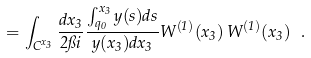Convert formula to latex. <formula><loc_0><loc_0><loc_500><loc_500>= \int _ { C ^ { x _ { 3 } } } \frac { d x _ { 3 } } { 2 \pi i } \frac { \int _ { q _ { 0 } } ^ { x _ { 3 } } y ( s ) d s } { y ( x _ { 3 } ) d x _ { 3 } } W ^ { ( 1 ) } ( x _ { 3 } ) \, W ^ { ( 1 ) } ( x _ { 3 } ) \, \ .</formula> 